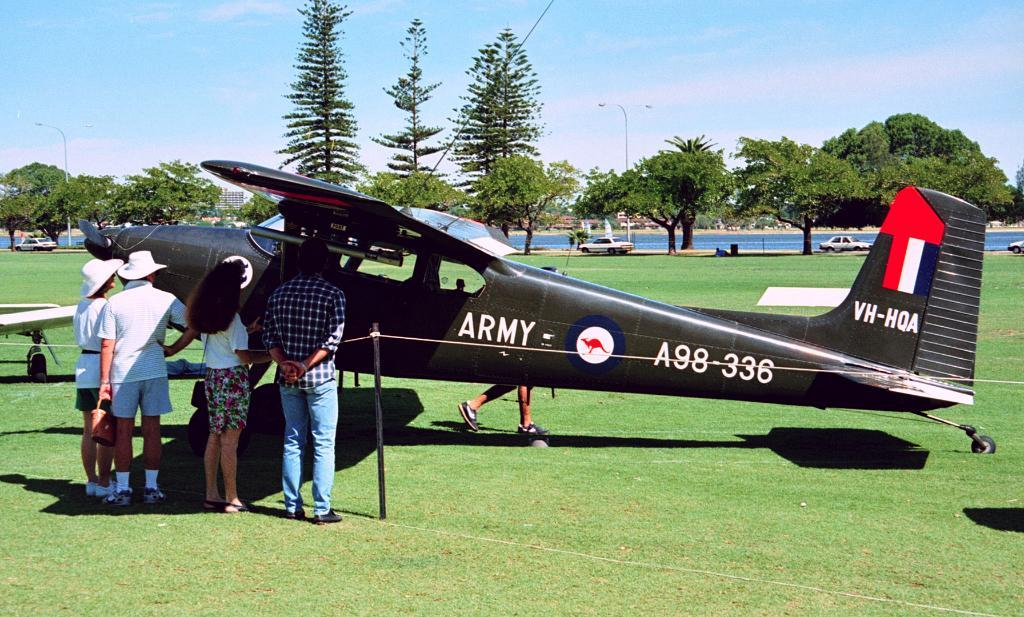<image>
Provide a brief description of the given image. people looking at a black plane with Army on the side 